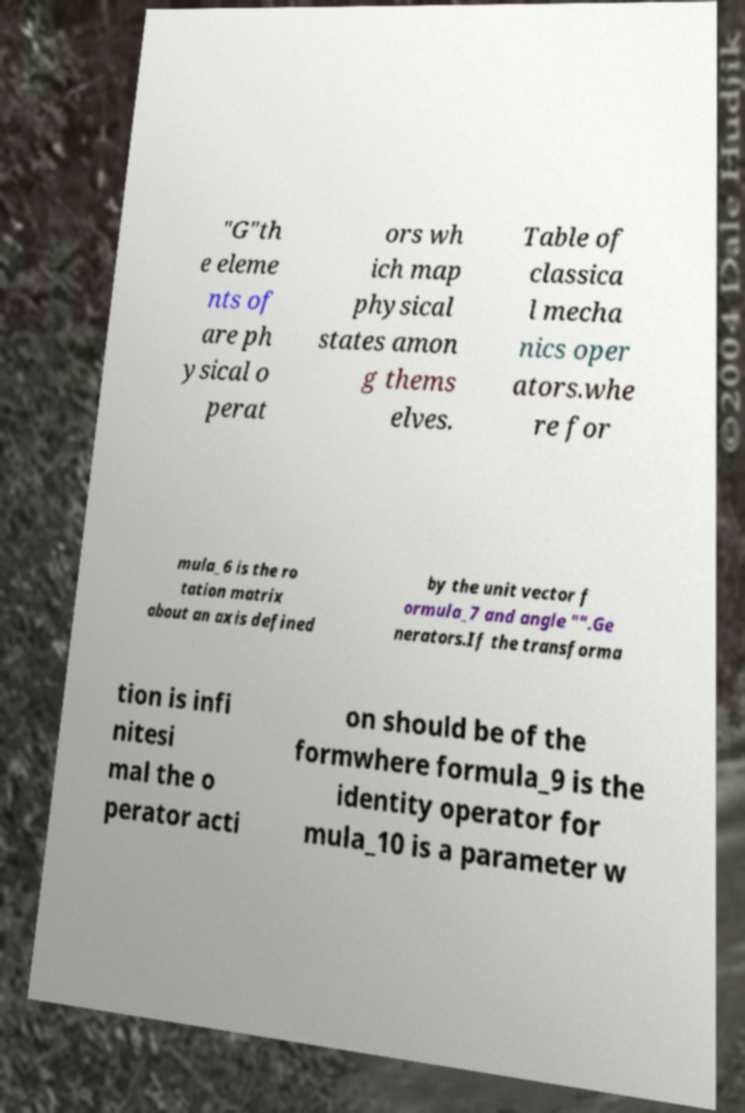What messages or text are displayed in this image? I need them in a readable, typed format. "G"th e eleme nts of are ph ysical o perat ors wh ich map physical states amon g thems elves. Table of classica l mecha nics oper ators.whe re for mula_6 is the ro tation matrix about an axis defined by the unit vector f ormula_7 and angle "".Ge nerators.If the transforma tion is infi nitesi mal the o perator acti on should be of the formwhere formula_9 is the identity operator for mula_10 is a parameter w 